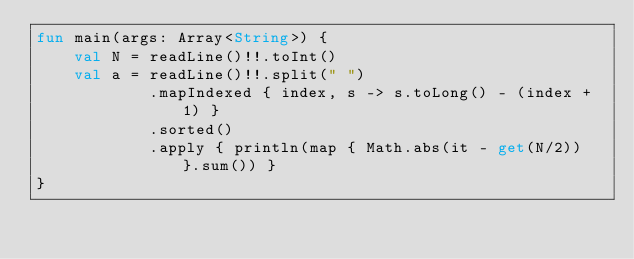Convert code to text. <code><loc_0><loc_0><loc_500><loc_500><_Kotlin_>fun main(args: Array<String>) {
    val N = readLine()!!.toInt()
    val a = readLine()!!.split(" ")
            .mapIndexed { index, s -> s.toLong() - (index + 1) }
            .sorted()
            .apply { println(map { Math.abs(it - get(N/2)) }.sum()) }
}</code> 